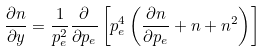<formula> <loc_0><loc_0><loc_500><loc_500>\frac { \partial n } { \partial y } = \frac { 1 } { p _ { e } ^ { 2 } } \frac { \partial } { \partial p _ { e } } \left [ p _ { e } ^ { 4 } \left ( \frac { \partial n } { \partial p _ { e } } + n + n ^ { 2 } \right ) \right ]</formula> 